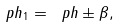<formula> <loc_0><loc_0><loc_500><loc_500>\ p h _ { 1 } = \ p h \pm \beta ,</formula> 